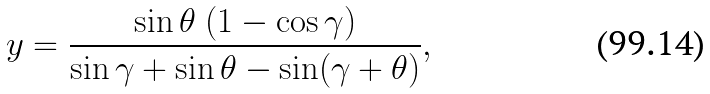Convert formula to latex. <formula><loc_0><loc_0><loc_500><loc_500>y = \frac { \sin \theta \ ( 1 - \cos \gamma ) } { \sin \gamma + \sin \theta - \sin ( \gamma + \theta ) } ,</formula> 